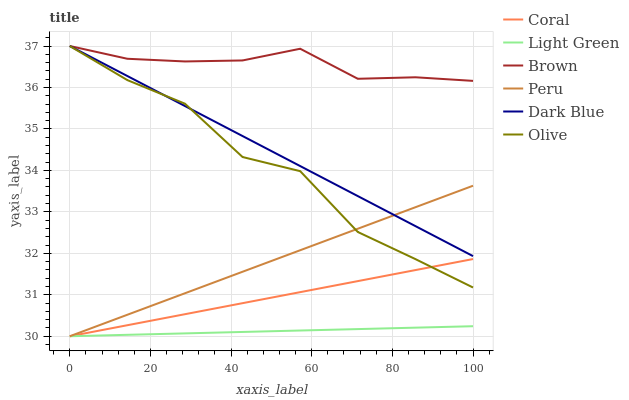Does Light Green have the minimum area under the curve?
Answer yes or no. Yes. Does Coral have the minimum area under the curve?
Answer yes or no. No. Does Coral have the maximum area under the curve?
Answer yes or no. No. Is Coral the smoothest?
Answer yes or no. No. Is Coral the roughest?
Answer yes or no. No. Does Dark Blue have the lowest value?
Answer yes or no. No. Does Coral have the highest value?
Answer yes or no. No. Is Peru less than Brown?
Answer yes or no. Yes. Is Brown greater than Peru?
Answer yes or no. Yes. Does Peru intersect Brown?
Answer yes or no. No. 